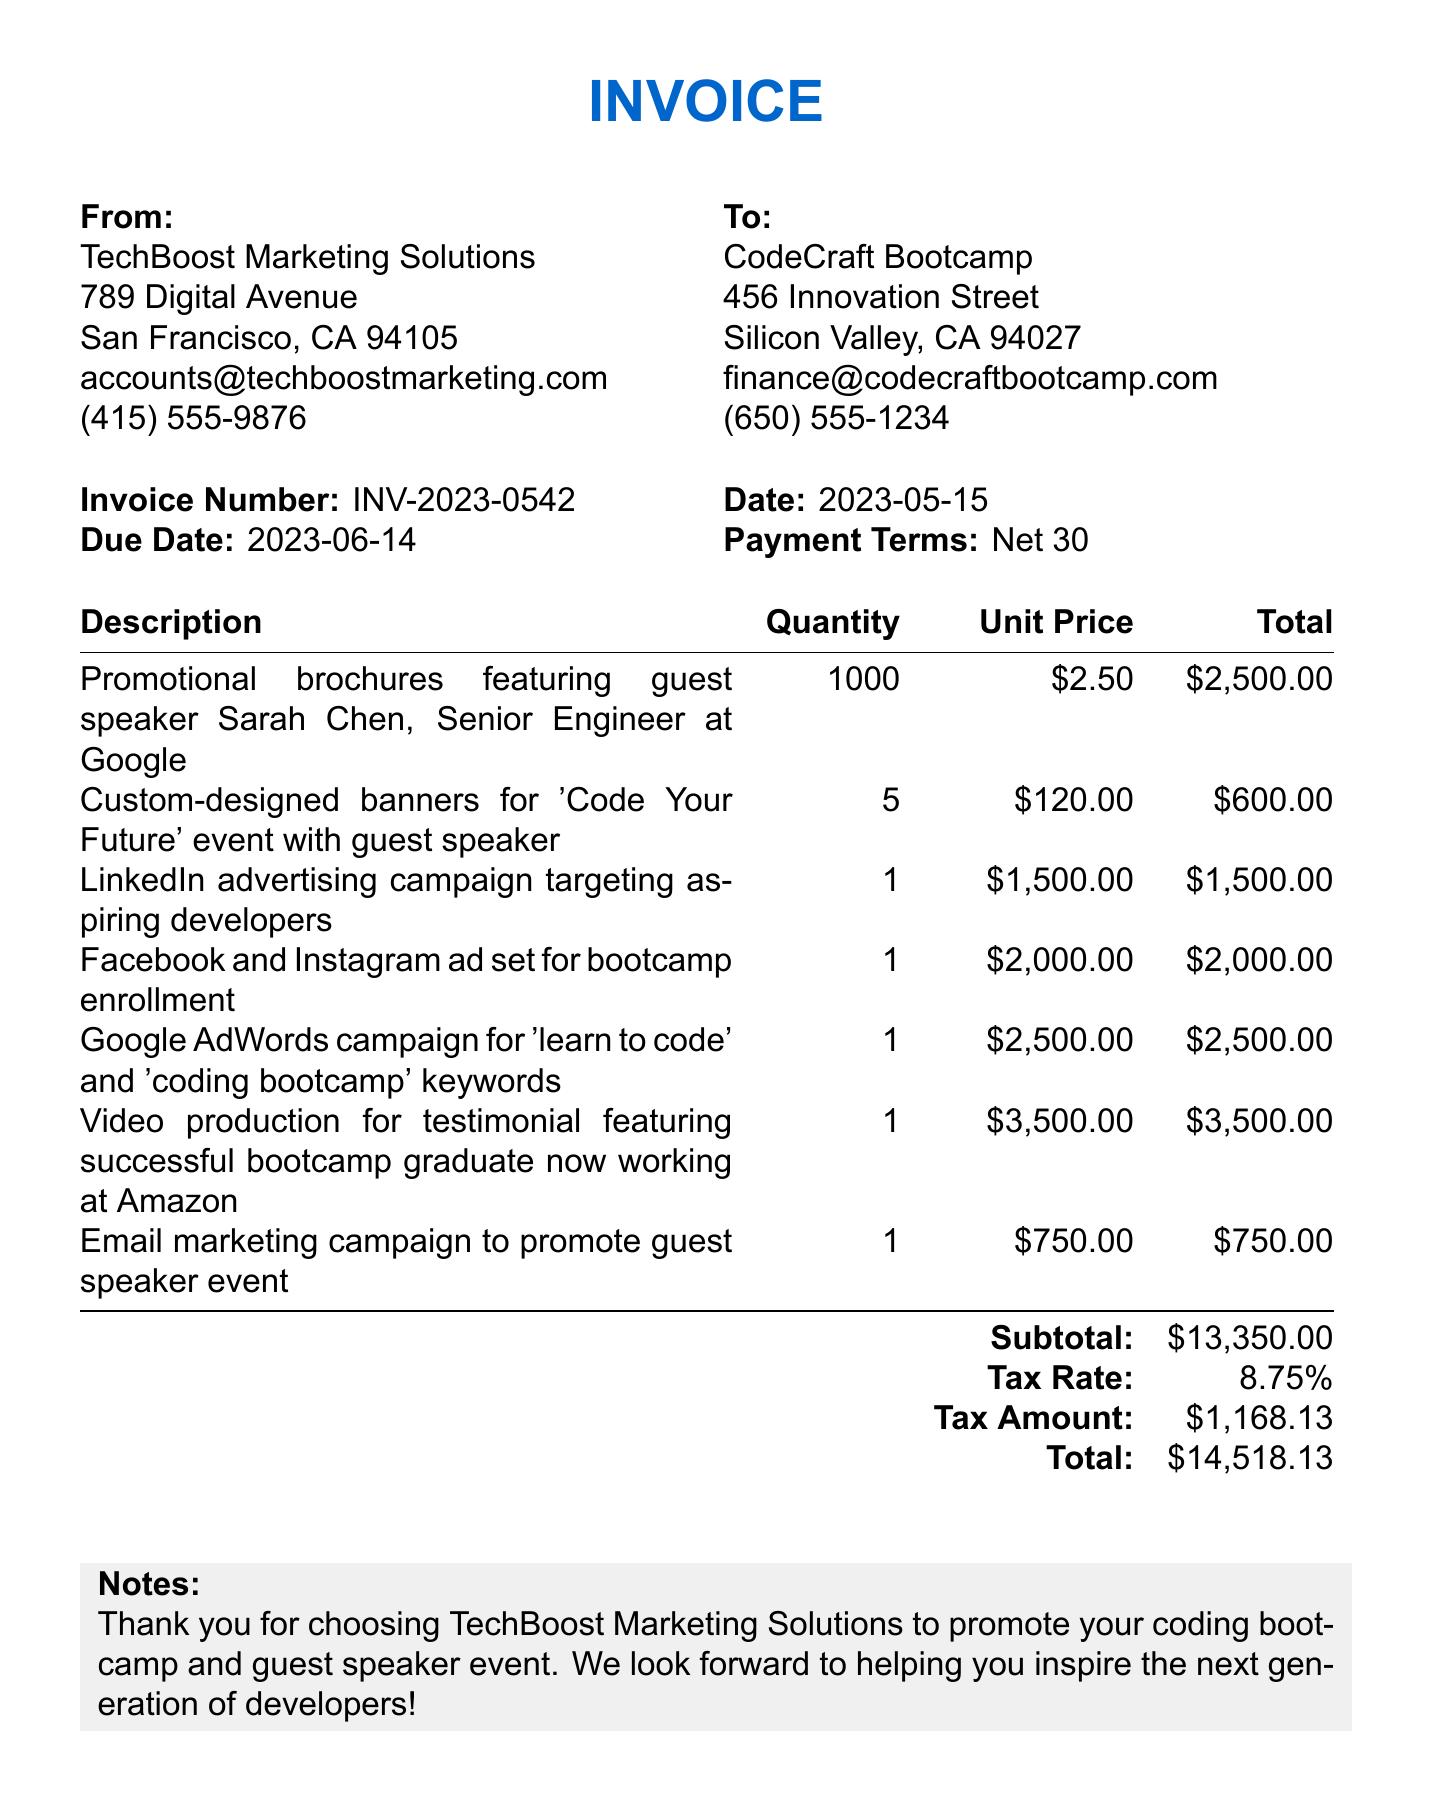What is the invoice number? The invoice number is explicitly listed in the document under the invoice details.
Answer: INV-2023-0542 Who is the guest speaker mentioned in the promotional brochures? The guest speaker's name is listed in the description of the promotional brochures in the items section of the invoice.
Answer: Sarah Chen What is the total amount due for this invoice? The total due is clearly stated at the end of the invoice under the total section.
Answer: 14518.13 What is the due date for the invoice? The due date is prominently mentioned alongside other important date-related information.
Answer: 2023-06-14 How many promotional brochures were ordered? The quantity of promotional brochures is specified in the items table.
Answer: 1000 What is the subtotal before tax? The subtotal is explicitly provided in the invoice before tax is calculated.
Answer: 13350.00 What type of payment terms are offered? The payment terms are mentioned directly in the invoice details.
Answer: Net 30 What is the tax rate applied to the invoice? The tax rate is listed in the invoice and is a percentage figure.
Answer: 8.75% What type of campaign is described for LinkedIn? The specific campaign type is found in the description of the LinkedIn advertising item.
Answer: advertising campaign targeting aspiring developers 